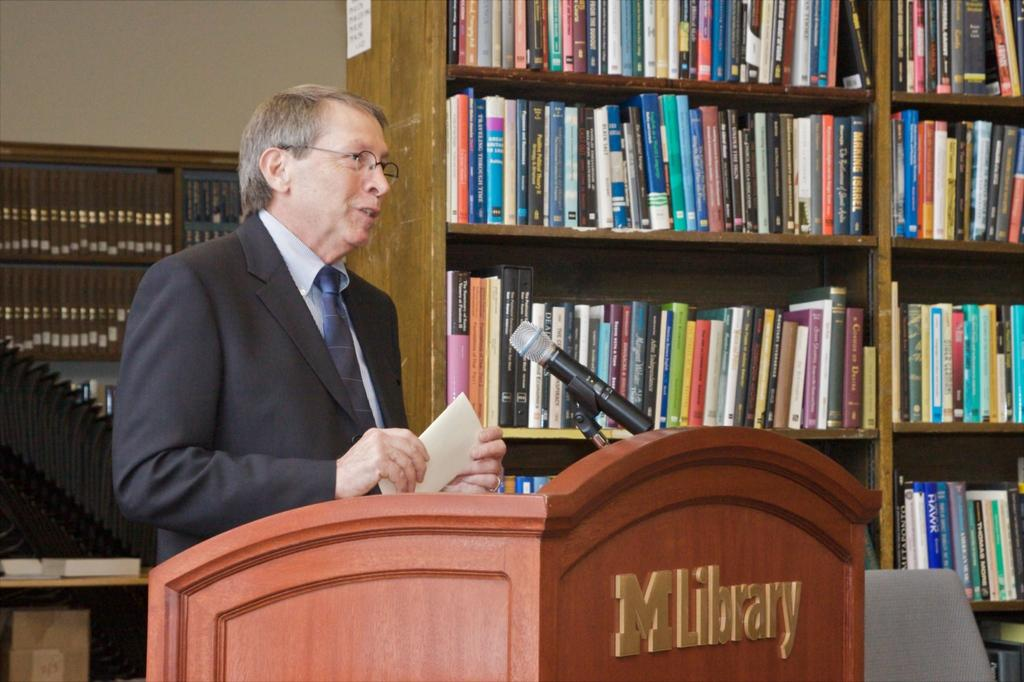<image>
Present a compact description of the photo's key features. A man standing in front of a podium that says MLibrary. 